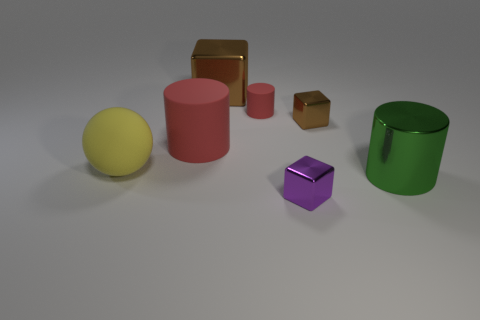Add 2 small blue cubes. How many objects exist? 9 Add 1 small rubber objects. How many small rubber objects exist? 2 Subtract 0 purple balls. How many objects are left? 7 Subtract all cubes. How many objects are left? 4 Subtract all tiny brown matte balls. Subtract all small red things. How many objects are left? 6 Add 5 small brown things. How many small brown things are left? 6 